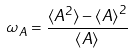Convert formula to latex. <formula><loc_0><loc_0><loc_500><loc_500>\omega _ { A } = \frac { \langle A ^ { 2 } \rangle - { \langle A \rangle } ^ { 2 } } { \langle A \rangle }</formula> 